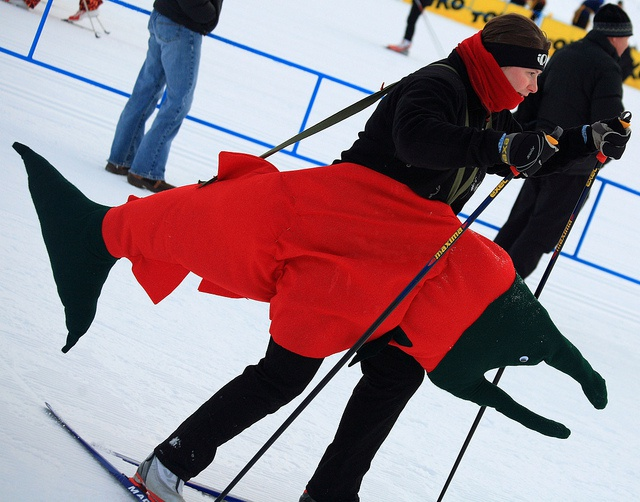Describe the objects in this image and their specific colors. I can see people in gray, black, maroon, and lightgray tones, people in gray, black, lavender, and brown tones, people in gray, blue, and black tones, people in gray, black, darkgray, and lightgray tones, and skis in gray, navy, lightgray, and darkgray tones in this image. 